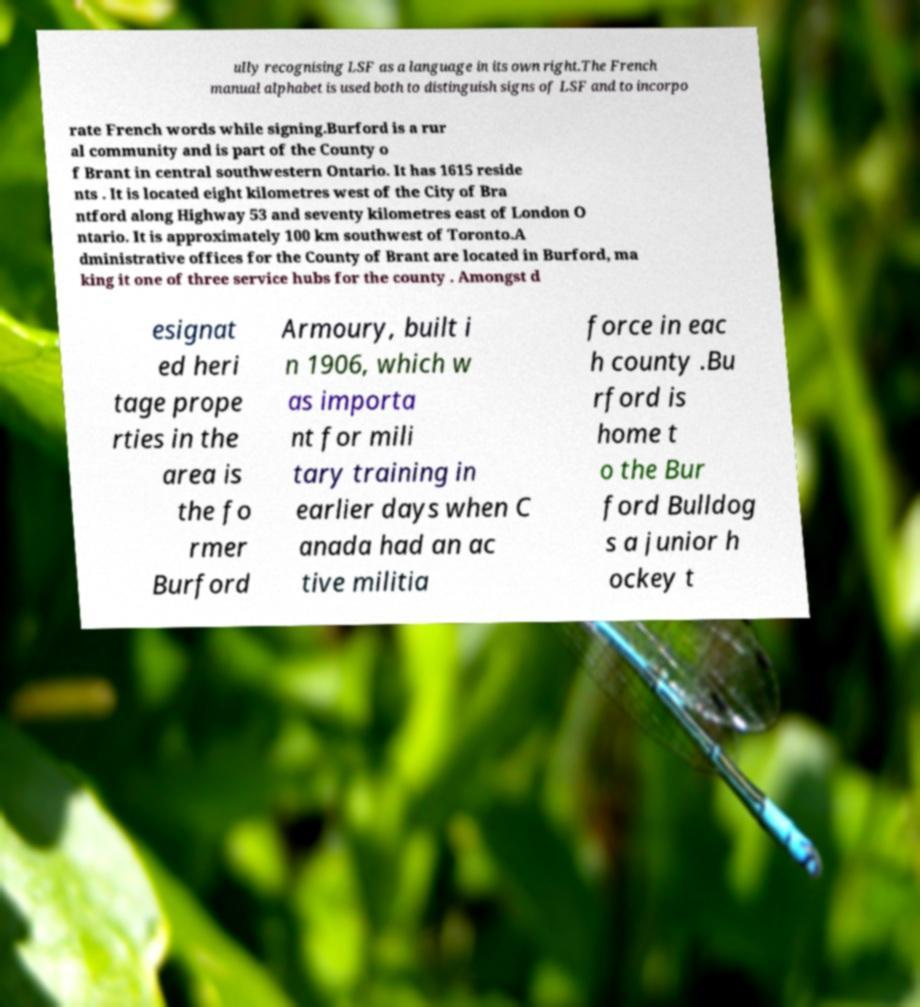Could you extract and type out the text from this image? ully recognising LSF as a language in its own right.The French manual alphabet is used both to distinguish signs of LSF and to incorpo rate French words while signing.Burford is a rur al community and is part of the County o f Brant in central southwestern Ontario. It has 1615 reside nts . It is located eight kilometres west of the City of Bra ntford along Highway 53 and seventy kilometres east of London O ntario. It is approximately 100 km southwest of Toronto.A dministrative offices for the County of Brant are located in Burford, ma king it one of three service hubs for the county . Amongst d esignat ed heri tage prope rties in the area is the fo rmer Burford Armoury, built i n 1906, which w as importa nt for mili tary training in earlier days when C anada had an ac tive militia force in eac h county .Bu rford is home t o the Bur ford Bulldog s a junior h ockey t 